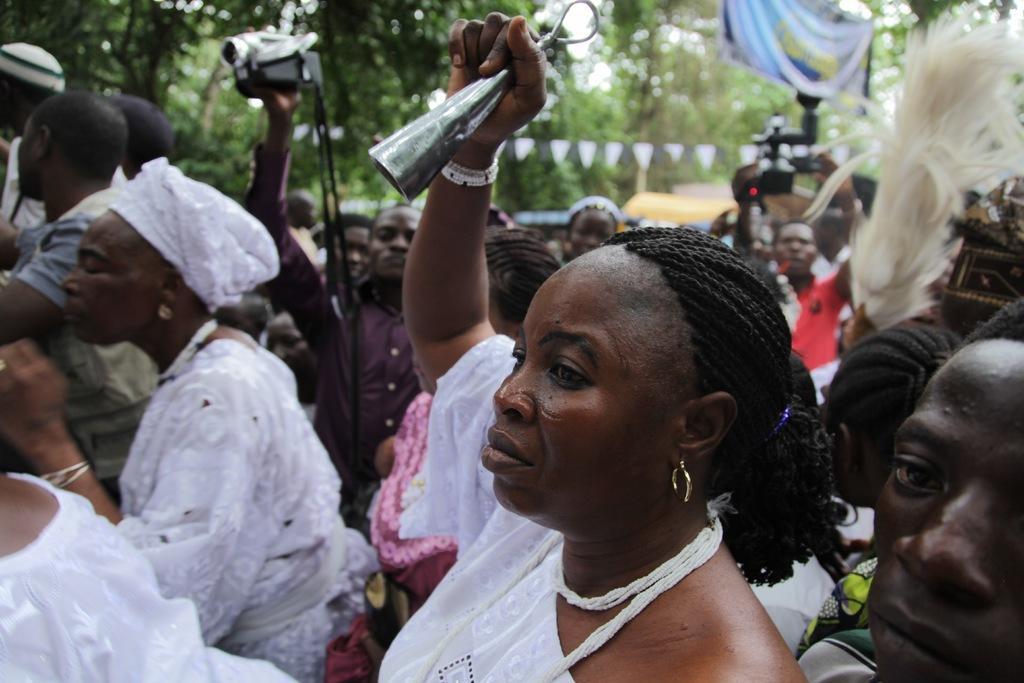Describe this image in one or two sentences. In this image we can see so many people, few are holding cameras in their hand and one lady is wearing white color dress and holding some bell like structure thing in her hand. Background of the image trees are present. 